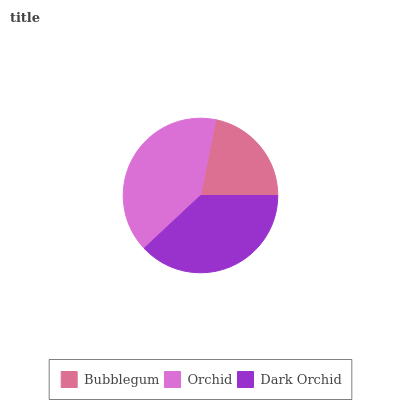Is Bubblegum the minimum?
Answer yes or no. Yes. Is Orchid the maximum?
Answer yes or no. Yes. Is Dark Orchid the minimum?
Answer yes or no. No. Is Dark Orchid the maximum?
Answer yes or no. No. Is Orchid greater than Dark Orchid?
Answer yes or no. Yes. Is Dark Orchid less than Orchid?
Answer yes or no. Yes. Is Dark Orchid greater than Orchid?
Answer yes or no. No. Is Orchid less than Dark Orchid?
Answer yes or no. No. Is Dark Orchid the high median?
Answer yes or no. Yes. Is Dark Orchid the low median?
Answer yes or no. Yes. Is Bubblegum the high median?
Answer yes or no. No. Is Orchid the low median?
Answer yes or no. No. 